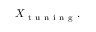<formula> <loc_0><loc_0><loc_500><loc_500>X _ { t u n i n g } .</formula> 